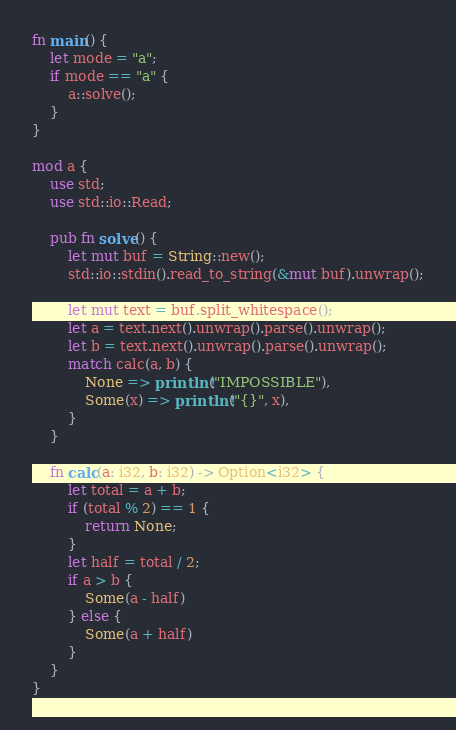Convert code to text. <code><loc_0><loc_0><loc_500><loc_500><_Rust_>fn main() {
    let mode = "a";
    if mode == "a" {
        a::solve();
    }
}

mod a {
    use std;
    use std::io::Read;

    pub fn solve() {
        let mut buf = String::new();
        std::io::stdin().read_to_string(&mut buf).unwrap();

        let mut text = buf.split_whitespace();
        let a = text.next().unwrap().parse().unwrap();
        let b = text.next().unwrap().parse().unwrap();
        match calc(a, b) {
            None => println!("IMPOSSIBLE"),
            Some(x) => println!("{}", x),
        }
    }

    fn calc(a: i32, b: i32) -> Option<i32> {
        let total = a + b;
        if (total % 2) == 1 {
            return None;
        }
        let half = total / 2;
        if a > b {
            Some(a - half)
        } else {
            Some(a + half)
        }
    }
}
</code> 